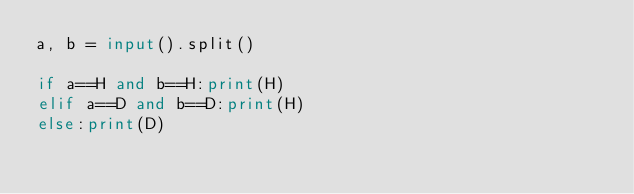Convert code to text. <code><loc_0><loc_0><loc_500><loc_500><_Python_>a, b = input().split()

if a==H and b==H:print(H)
elif a==D and b==D:print(H)
else:print(D)</code> 